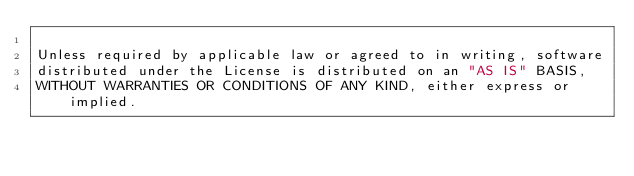Convert code to text. <code><loc_0><loc_0><loc_500><loc_500><_Python_>
Unless required by applicable law or agreed to in writing, software
distributed under the License is distributed on an "AS IS" BASIS,
WITHOUT WARRANTIES OR CONDITIONS OF ANY KIND, either express or implied.</code> 